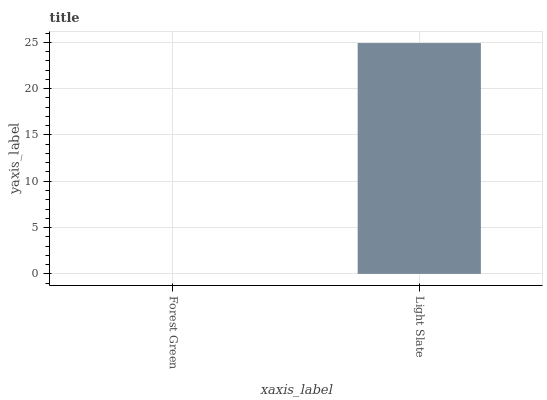Is Forest Green the minimum?
Answer yes or no. Yes. Is Light Slate the maximum?
Answer yes or no. Yes. Is Light Slate the minimum?
Answer yes or no. No. Is Light Slate greater than Forest Green?
Answer yes or no. Yes. Is Forest Green less than Light Slate?
Answer yes or no. Yes. Is Forest Green greater than Light Slate?
Answer yes or no. No. Is Light Slate less than Forest Green?
Answer yes or no. No. Is Light Slate the high median?
Answer yes or no. Yes. Is Forest Green the low median?
Answer yes or no. Yes. Is Forest Green the high median?
Answer yes or no. No. Is Light Slate the low median?
Answer yes or no. No. 